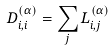<formula> <loc_0><loc_0><loc_500><loc_500>D _ { i , i } ^ { ( \alpha ) } = \sum _ { j } L _ { i , j } ^ { ( \alpha ) }</formula> 